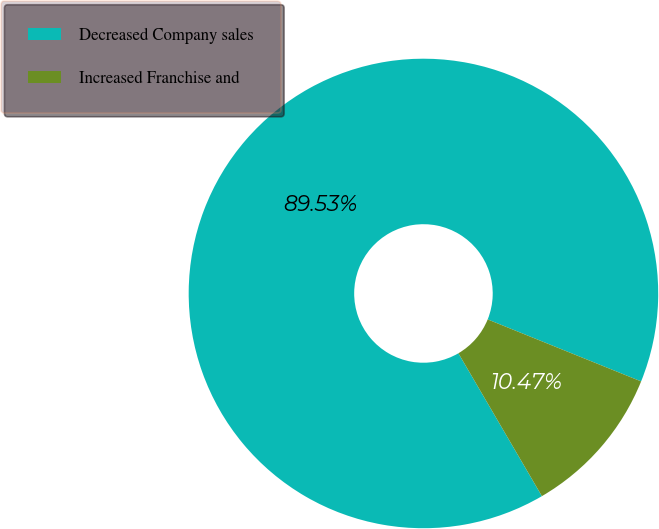Convert chart. <chart><loc_0><loc_0><loc_500><loc_500><pie_chart><fcel>Decreased Company sales<fcel>Increased Franchise and<nl><fcel>89.53%<fcel>10.47%<nl></chart> 